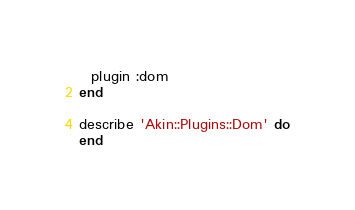<code> <loc_0><loc_0><loc_500><loc_500><_Ruby_>
  plugin :dom
end

describe 'Akin::Plugins::Dom' do
end
</code> 